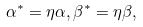<formula> <loc_0><loc_0><loc_500><loc_500>\alpha ^ { * } = \eta \alpha , \beta ^ { * } = \eta \beta ,</formula> 